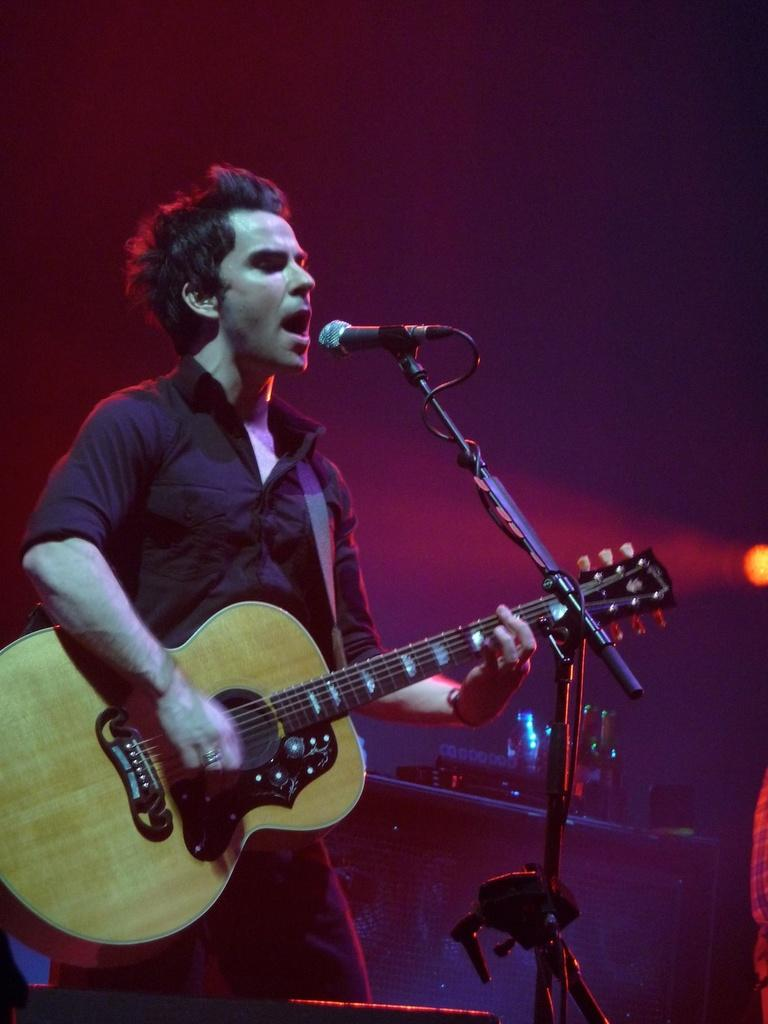What is the man in the image doing? The man is playing a guitar and singing a song. What is the man wearing in the image? The man is wearing a black shirt. What object is the man holding in the image? The man is holding a microphone. Can you see any cherries on the man's shirt in the image? There are no cherries visible on the man's shirt in the image. Who is the man's friend in the image? There is no friend present in the image; it only shows the man playing the guitar and singing a song. 